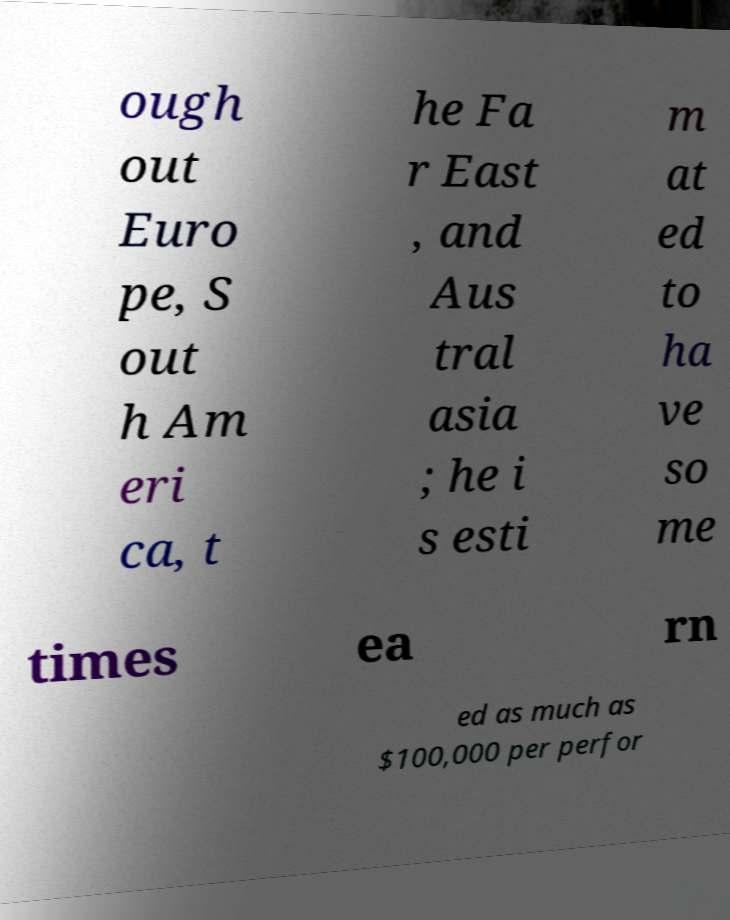Please identify and transcribe the text found in this image. ough out Euro pe, S out h Am eri ca, t he Fa r East , and Aus tral asia ; he i s esti m at ed to ha ve so me times ea rn ed as much as $100,000 per perfor 